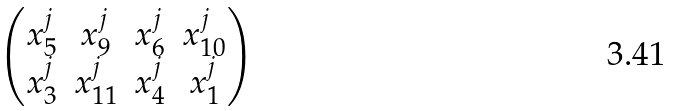Convert formula to latex. <formula><loc_0><loc_0><loc_500><loc_500>\begin{pmatrix} x _ { 5 } ^ { j } & x _ { 9 } ^ { j } & x _ { 6 } ^ { j } & x _ { 1 0 } ^ { j } \\ x _ { 3 } ^ { j } & x _ { 1 1 } ^ { j } & x _ { 4 } ^ { j } & x _ { 1 } ^ { j } \end{pmatrix}</formula> 